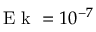<formula> <loc_0><loc_0><loc_500><loc_500>E k = 1 0 ^ { - 7 }</formula> 